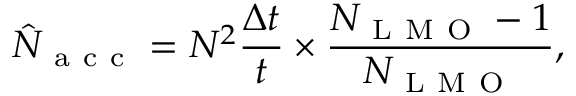<formula> <loc_0><loc_0><loc_500><loc_500>\hat { N } _ { a c c } = N ^ { 2 } \frac { \Delta t } { t } \times \frac { N _ { L M O } - 1 } { N _ { L M O } } ,</formula> 